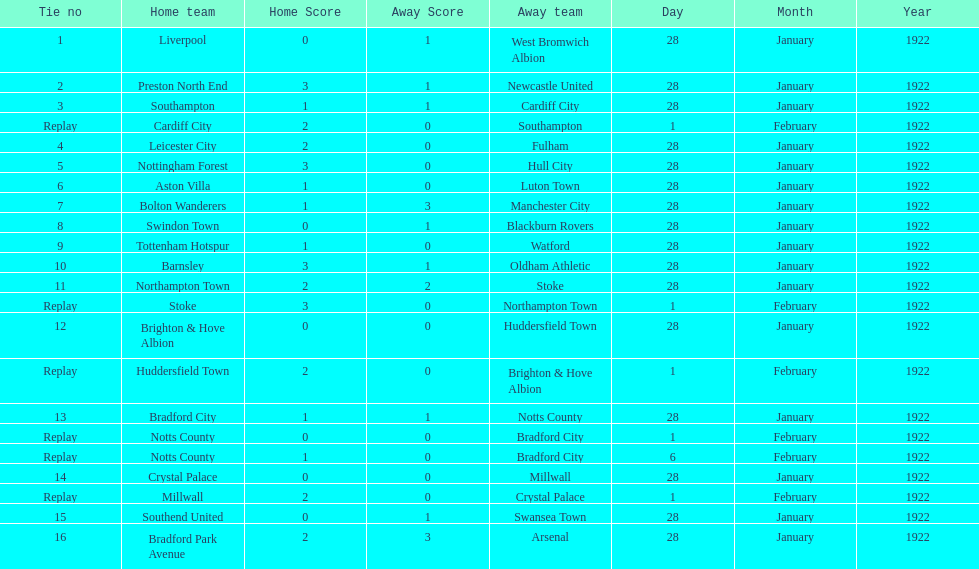What home team had the same score as aston villa on january 28th, 1922? Tottenham Hotspur. 